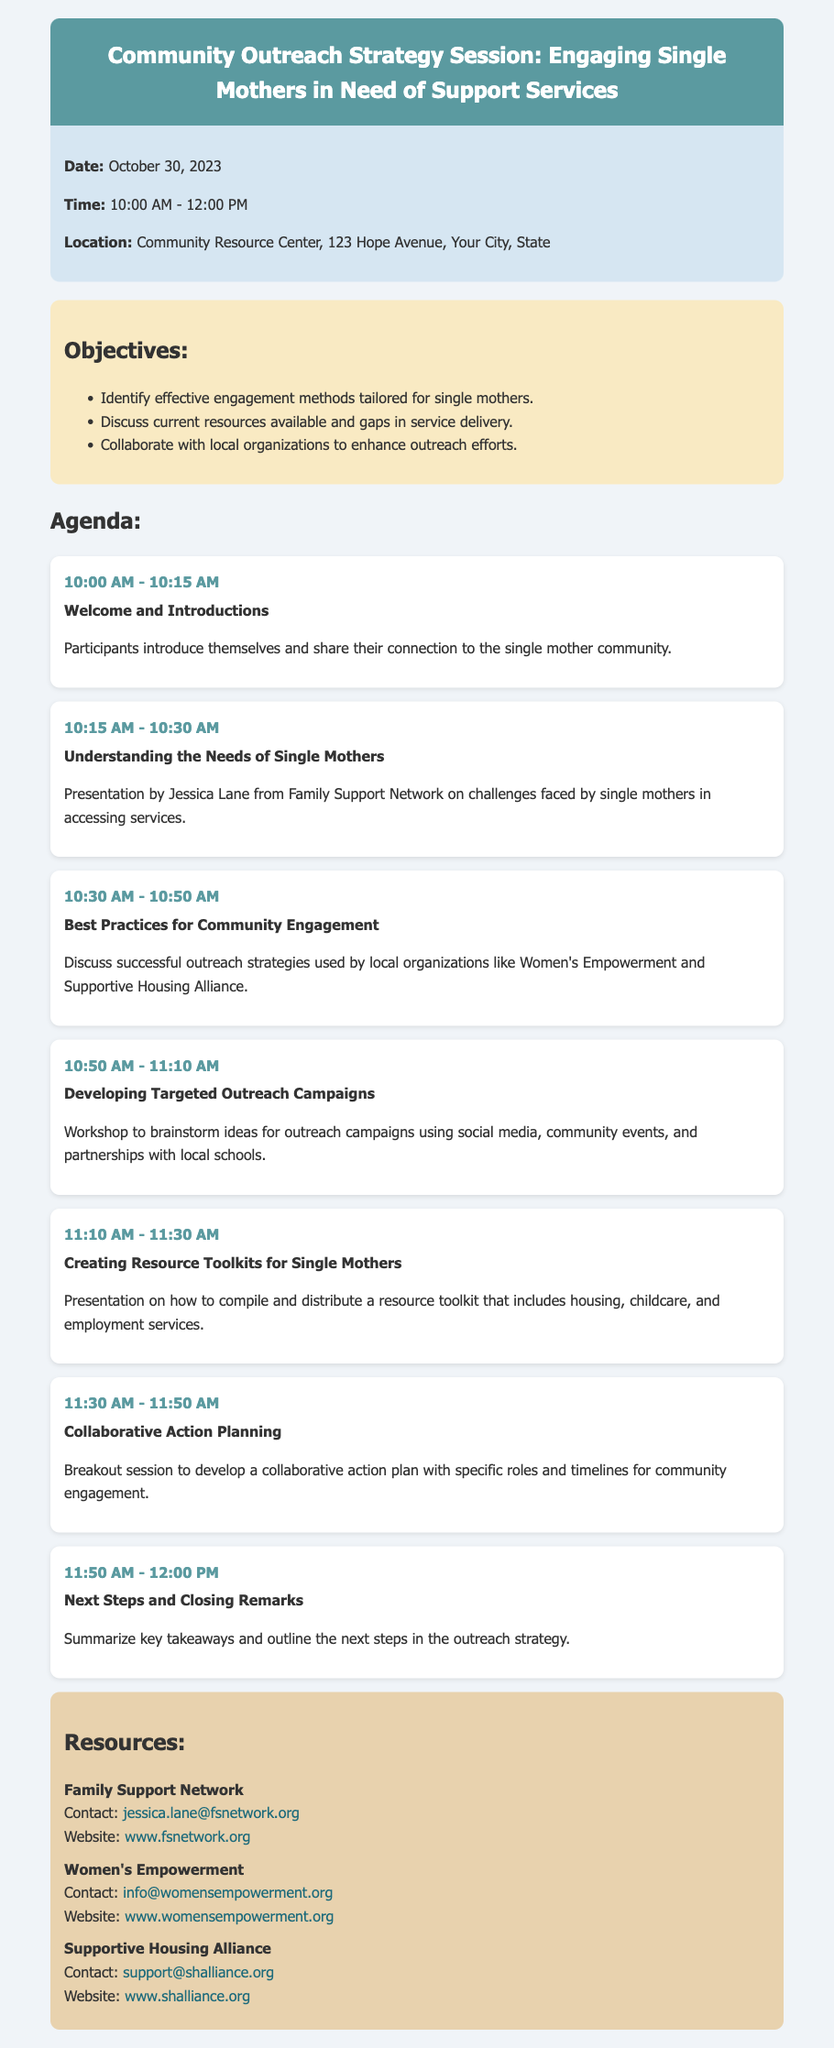What is the date of the strategy session? The date of the strategy session is mentioned in the document as October 30, 2023.
Answer: October 30, 2023 What is the location of the Community Resource Center? The document specifies the address of the Community Resource Center as 123 Hope Avenue, Your City, State.
Answer: 123 Hope Avenue, Your City, State Which organization is Jessica Lane from? The document indicates that Jessica Lane is from the Family Support Network during her presentation.
Answer: Family Support Network What is one of the objectives of the session? The document lists objectives, including identifying effective engagement methods tailored for single mothers.
Answer: Identify effective engagement methods tailored for single mothers At what time does the Welcome and Introductions begin? The document outlines that the Welcome and Introductions start at 10:00 AM.
Answer: 10:00 AM What topic is scheduled for 10:50 AM? The document mentions that the topic for 10:50 AM is Developing Targeted Outreach Campaigns.
Answer: Developing Targeted Outreach Campaigns What type of session is planned at 11:30 AM? The agenda specifies a breakout session for Collaborative Action Planning at that time.
Answer: Breakout session Who can be contacted at the Women's Empowerment organization? The document provides contact information for the Women's Empowerment organization, specifically noting the email address info@womensempowerment.org.
Answer: info@womensempowerment.org 